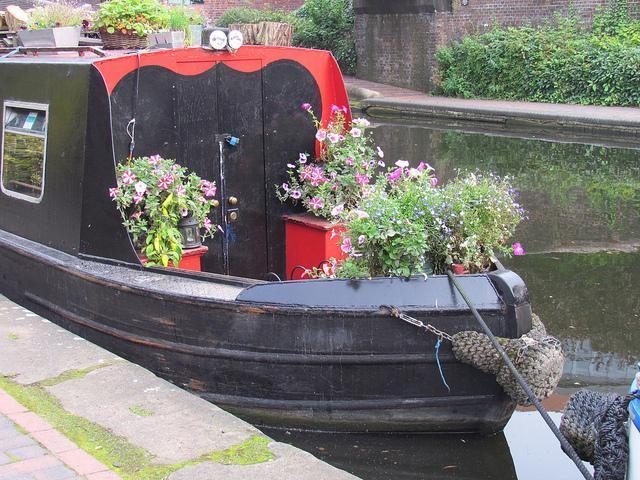How many potted plants are there?
Give a very brief answer. 5. How many trains are in the picture?
Give a very brief answer. 0. 